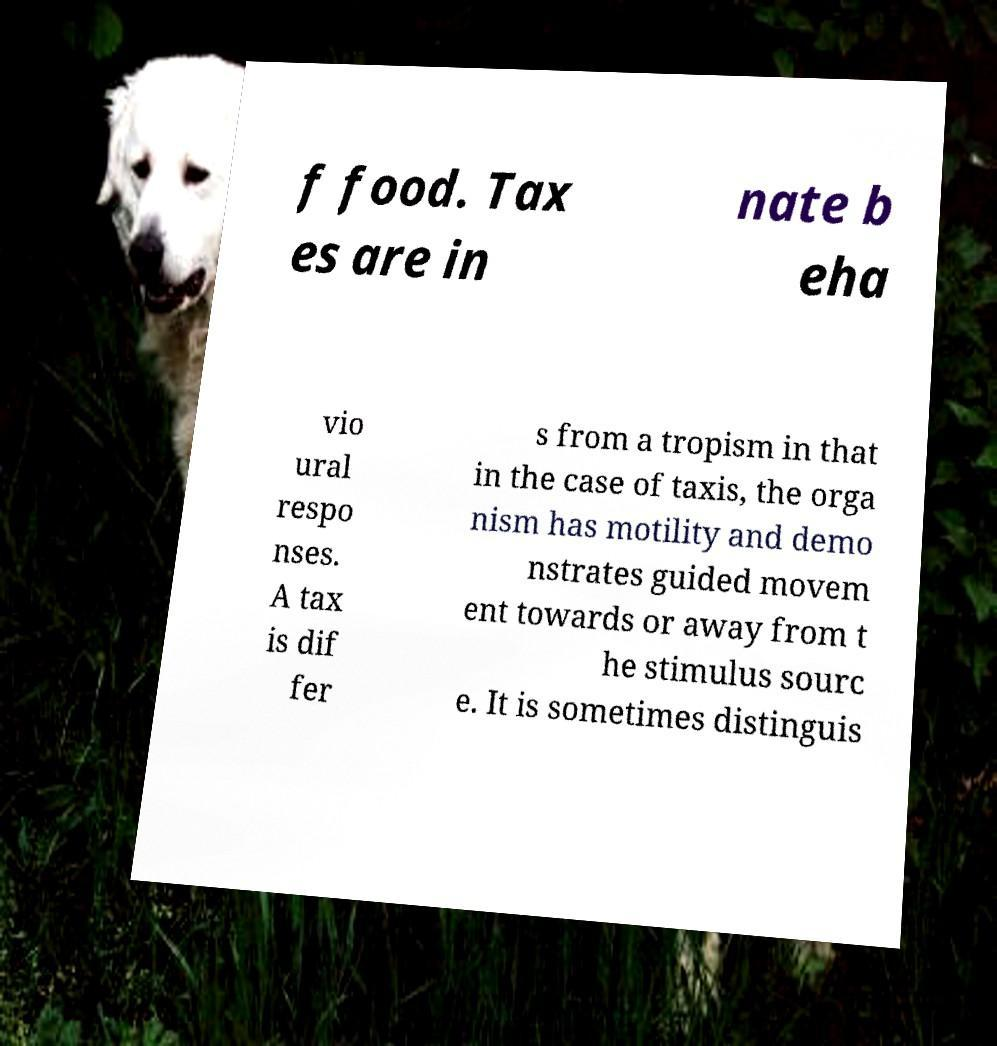Could you assist in decoding the text presented in this image and type it out clearly? f food. Tax es are in nate b eha vio ural respo nses. A tax is dif fer s from a tropism in that in the case of taxis, the orga nism has motility and demo nstrates guided movem ent towards or away from t he stimulus sourc e. It is sometimes distinguis 